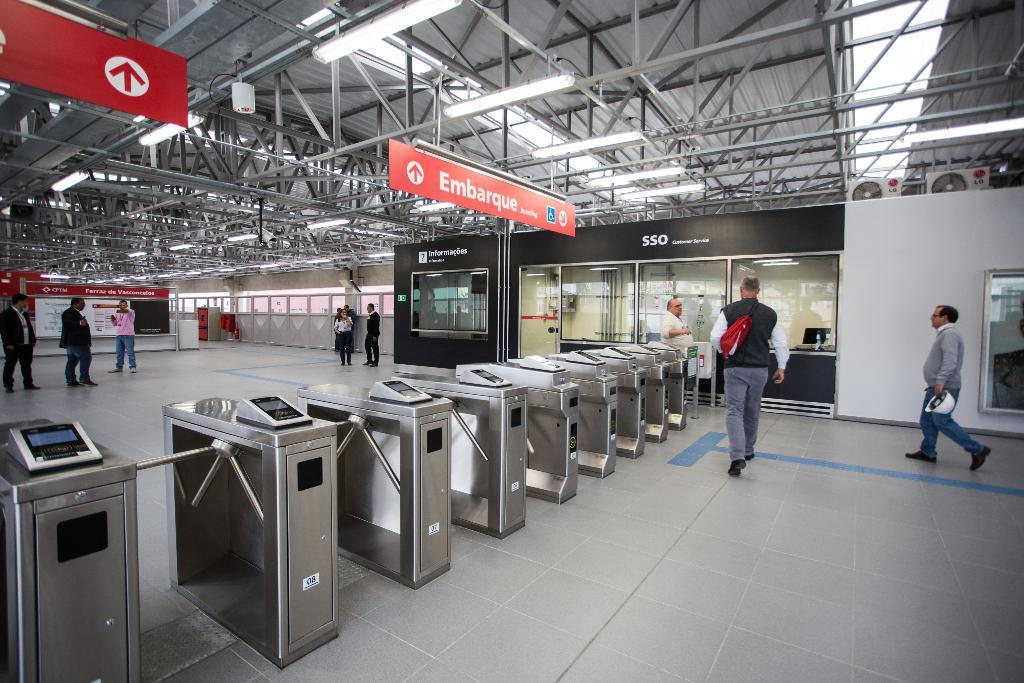<image>
Relay a brief, clear account of the picture shown. A train station entrance with a banner that says Embarque. 